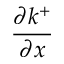Convert formula to latex. <formula><loc_0><loc_0><loc_500><loc_500>\frac { \partial k ^ { + } } { \partial x }</formula> 